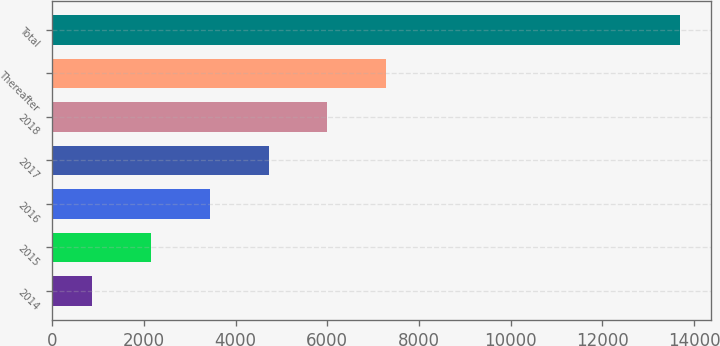Convert chart. <chart><loc_0><loc_0><loc_500><loc_500><bar_chart><fcel>2014<fcel>2015<fcel>2016<fcel>2017<fcel>2018<fcel>Thereafter<fcel>Total<nl><fcel>877<fcel>2158.1<fcel>3439.2<fcel>4720.3<fcel>6001.4<fcel>7282.5<fcel>13688<nl></chart> 